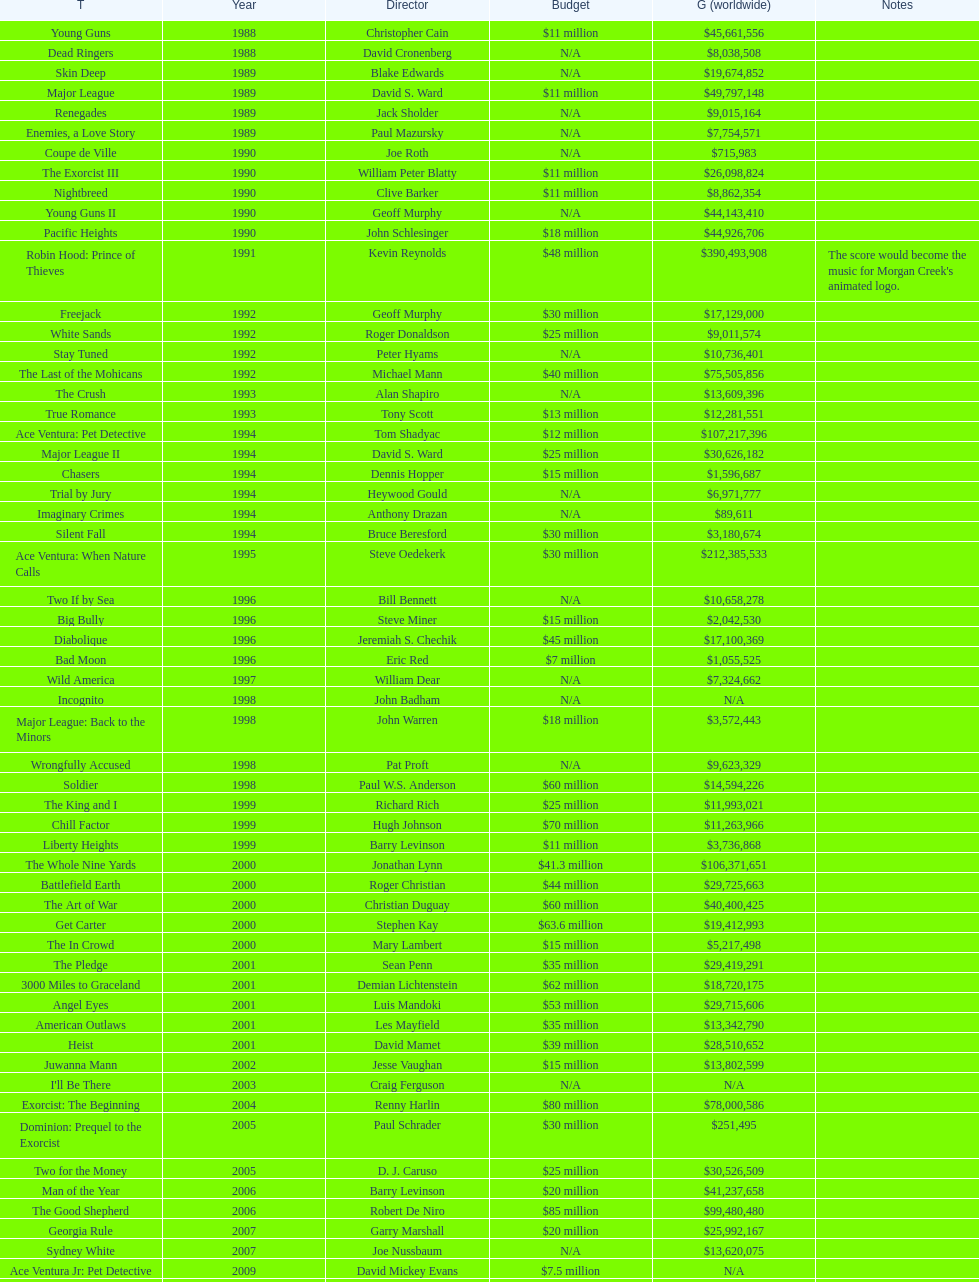Which film produced by morgan creek had the highest worldwide gross? Robin Hood: Prince of Thieves. 